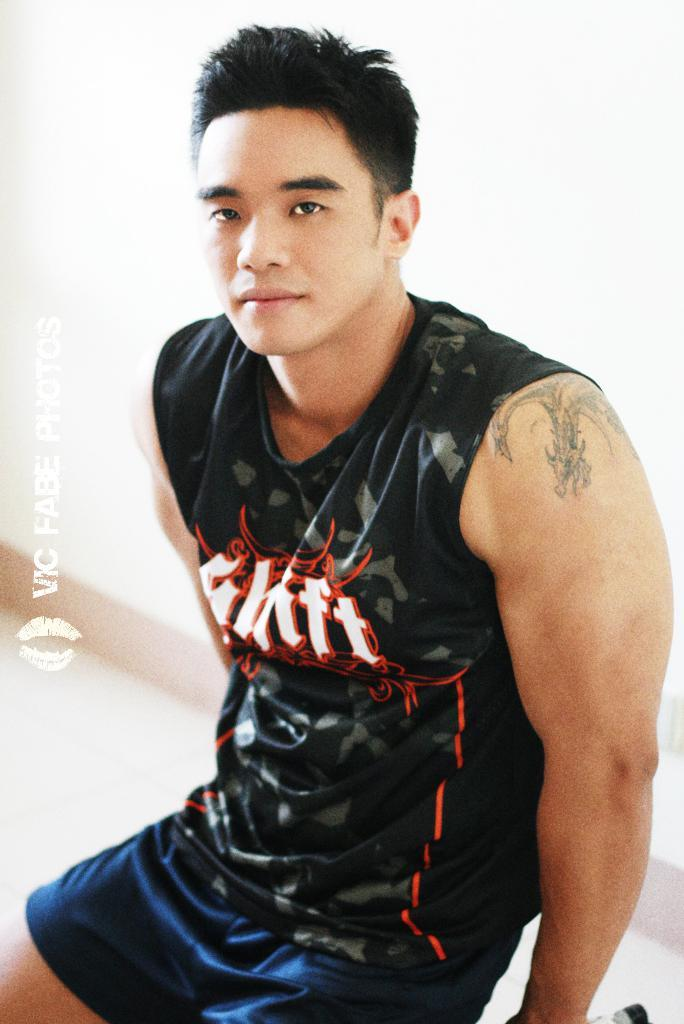<image>
Offer a succinct explanation of the picture presented. A man is wearing a tank top that has a word on it that ends in with the letter T. 